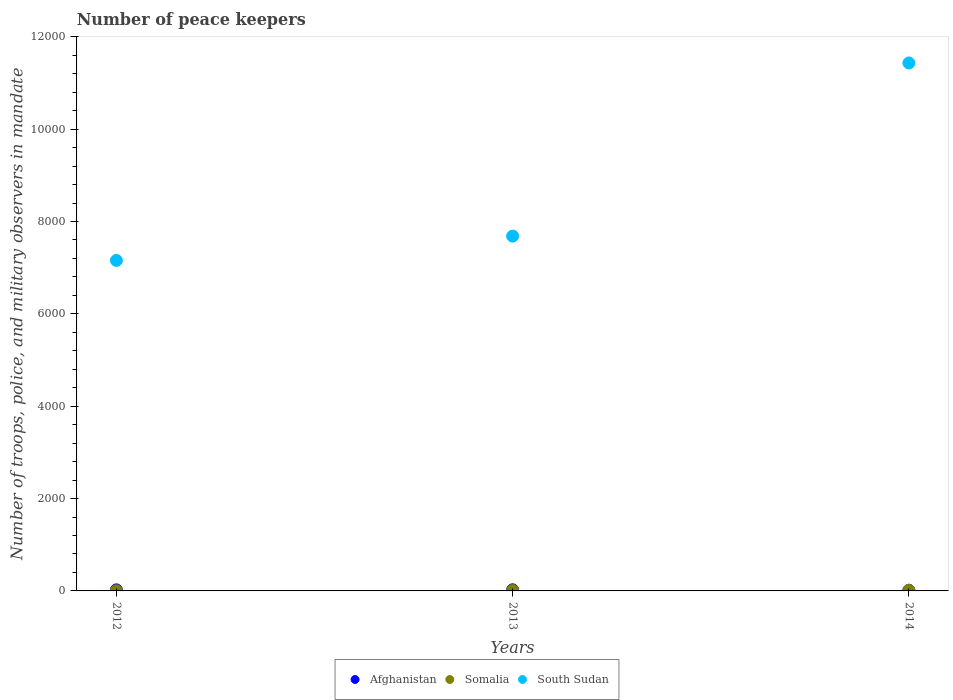How many different coloured dotlines are there?
Provide a short and direct response. 3. Across all years, what is the maximum number of peace keepers in in South Sudan?
Provide a short and direct response. 1.14e+04. Across all years, what is the minimum number of peace keepers in in South Sudan?
Make the answer very short. 7157. What is the total number of peace keepers in in Afghanistan in the graph?
Keep it short and to the point. 63. What is the difference between the number of peace keepers in in Somalia in 2012 and that in 2014?
Offer a very short reply. -9. What is the difference between the number of peace keepers in in Afghanistan in 2014 and the number of peace keepers in in South Sudan in 2012?
Provide a short and direct response. -7142. What is the average number of peace keepers in in South Sudan per year?
Your response must be concise. 8758. In the year 2013, what is the difference between the number of peace keepers in in South Sudan and number of peace keepers in in Somalia?
Give a very brief answer. 7675. What is the ratio of the number of peace keepers in in Afghanistan in 2012 to that in 2014?
Ensure brevity in your answer.  1.53. Is the number of peace keepers in in Afghanistan in 2012 less than that in 2013?
Offer a very short reply. Yes. What is the difference between the highest and the second highest number of peace keepers in in Afghanistan?
Your answer should be compact. 2. Is the sum of the number of peace keepers in in Afghanistan in 2013 and 2014 greater than the maximum number of peace keepers in in South Sudan across all years?
Ensure brevity in your answer.  No. Does the number of peace keepers in in South Sudan monotonically increase over the years?
Offer a terse response. Yes. Is the number of peace keepers in in Afghanistan strictly greater than the number of peace keepers in in South Sudan over the years?
Your answer should be very brief. No. How many years are there in the graph?
Provide a succinct answer. 3. What is the difference between two consecutive major ticks on the Y-axis?
Your answer should be very brief. 2000. Are the values on the major ticks of Y-axis written in scientific E-notation?
Your response must be concise. No. How are the legend labels stacked?
Offer a very short reply. Horizontal. What is the title of the graph?
Provide a short and direct response. Number of peace keepers. Does "Sao Tome and Principe" appear as one of the legend labels in the graph?
Ensure brevity in your answer.  No. What is the label or title of the Y-axis?
Offer a terse response. Number of troops, police, and military observers in mandate. What is the Number of troops, police, and military observers in mandate of Afghanistan in 2012?
Your answer should be compact. 23. What is the Number of troops, police, and military observers in mandate of South Sudan in 2012?
Provide a succinct answer. 7157. What is the Number of troops, police, and military observers in mandate in Somalia in 2013?
Give a very brief answer. 9. What is the Number of troops, police, and military observers in mandate in South Sudan in 2013?
Provide a short and direct response. 7684. What is the Number of troops, police, and military observers in mandate in Afghanistan in 2014?
Give a very brief answer. 15. What is the Number of troops, police, and military observers in mandate in South Sudan in 2014?
Your answer should be very brief. 1.14e+04. Across all years, what is the maximum Number of troops, police, and military observers in mandate of Afghanistan?
Give a very brief answer. 25. Across all years, what is the maximum Number of troops, police, and military observers in mandate in Somalia?
Offer a very short reply. 12. Across all years, what is the maximum Number of troops, police, and military observers in mandate in South Sudan?
Offer a terse response. 1.14e+04. Across all years, what is the minimum Number of troops, police, and military observers in mandate in Somalia?
Keep it short and to the point. 3. Across all years, what is the minimum Number of troops, police, and military observers in mandate of South Sudan?
Give a very brief answer. 7157. What is the total Number of troops, police, and military observers in mandate in Afghanistan in the graph?
Offer a very short reply. 63. What is the total Number of troops, police, and military observers in mandate of South Sudan in the graph?
Provide a succinct answer. 2.63e+04. What is the difference between the Number of troops, police, and military observers in mandate of Afghanistan in 2012 and that in 2013?
Provide a succinct answer. -2. What is the difference between the Number of troops, police, and military observers in mandate of Somalia in 2012 and that in 2013?
Your response must be concise. -6. What is the difference between the Number of troops, police, and military observers in mandate in South Sudan in 2012 and that in 2013?
Ensure brevity in your answer.  -527. What is the difference between the Number of troops, police, and military observers in mandate in South Sudan in 2012 and that in 2014?
Ensure brevity in your answer.  -4276. What is the difference between the Number of troops, police, and military observers in mandate in South Sudan in 2013 and that in 2014?
Offer a very short reply. -3749. What is the difference between the Number of troops, police, and military observers in mandate of Afghanistan in 2012 and the Number of troops, police, and military observers in mandate of South Sudan in 2013?
Keep it short and to the point. -7661. What is the difference between the Number of troops, police, and military observers in mandate in Somalia in 2012 and the Number of troops, police, and military observers in mandate in South Sudan in 2013?
Your response must be concise. -7681. What is the difference between the Number of troops, police, and military observers in mandate in Afghanistan in 2012 and the Number of troops, police, and military observers in mandate in South Sudan in 2014?
Provide a short and direct response. -1.14e+04. What is the difference between the Number of troops, police, and military observers in mandate of Somalia in 2012 and the Number of troops, police, and military observers in mandate of South Sudan in 2014?
Your answer should be very brief. -1.14e+04. What is the difference between the Number of troops, police, and military observers in mandate in Afghanistan in 2013 and the Number of troops, police, and military observers in mandate in Somalia in 2014?
Your answer should be compact. 13. What is the difference between the Number of troops, police, and military observers in mandate in Afghanistan in 2013 and the Number of troops, police, and military observers in mandate in South Sudan in 2014?
Offer a terse response. -1.14e+04. What is the difference between the Number of troops, police, and military observers in mandate of Somalia in 2013 and the Number of troops, police, and military observers in mandate of South Sudan in 2014?
Provide a short and direct response. -1.14e+04. What is the average Number of troops, police, and military observers in mandate of South Sudan per year?
Your answer should be compact. 8758. In the year 2012, what is the difference between the Number of troops, police, and military observers in mandate of Afghanistan and Number of troops, police, and military observers in mandate of Somalia?
Your answer should be very brief. 20. In the year 2012, what is the difference between the Number of troops, police, and military observers in mandate in Afghanistan and Number of troops, police, and military observers in mandate in South Sudan?
Your answer should be very brief. -7134. In the year 2012, what is the difference between the Number of troops, police, and military observers in mandate in Somalia and Number of troops, police, and military observers in mandate in South Sudan?
Provide a short and direct response. -7154. In the year 2013, what is the difference between the Number of troops, police, and military observers in mandate in Afghanistan and Number of troops, police, and military observers in mandate in Somalia?
Offer a terse response. 16. In the year 2013, what is the difference between the Number of troops, police, and military observers in mandate in Afghanistan and Number of troops, police, and military observers in mandate in South Sudan?
Your answer should be compact. -7659. In the year 2013, what is the difference between the Number of troops, police, and military observers in mandate of Somalia and Number of troops, police, and military observers in mandate of South Sudan?
Make the answer very short. -7675. In the year 2014, what is the difference between the Number of troops, police, and military observers in mandate of Afghanistan and Number of troops, police, and military observers in mandate of Somalia?
Keep it short and to the point. 3. In the year 2014, what is the difference between the Number of troops, police, and military observers in mandate in Afghanistan and Number of troops, police, and military observers in mandate in South Sudan?
Your response must be concise. -1.14e+04. In the year 2014, what is the difference between the Number of troops, police, and military observers in mandate in Somalia and Number of troops, police, and military observers in mandate in South Sudan?
Your answer should be very brief. -1.14e+04. What is the ratio of the Number of troops, police, and military observers in mandate in Afghanistan in 2012 to that in 2013?
Offer a very short reply. 0.92. What is the ratio of the Number of troops, police, and military observers in mandate in South Sudan in 2012 to that in 2013?
Offer a very short reply. 0.93. What is the ratio of the Number of troops, police, and military observers in mandate in Afghanistan in 2012 to that in 2014?
Your response must be concise. 1.53. What is the ratio of the Number of troops, police, and military observers in mandate of South Sudan in 2012 to that in 2014?
Keep it short and to the point. 0.63. What is the ratio of the Number of troops, police, and military observers in mandate of Afghanistan in 2013 to that in 2014?
Offer a very short reply. 1.67. What is the ratio of the Number of troops, police, and military observers in mandate in Somalia in 2013 to that in 2014?
Your answer should be very brief. 0.75. What is the ratio of the Number of troops, police, and military observers in mandate in South Sudan in 2013 to that in 2014?
Give a very brief answer. 0.67. What is the difference between the highest and the second highest Number of troops, police, and military observers in mandate in Afghanistan?
Give a very brief answer. 2. What is the difference between the highest and the second highest Number of troops, police, and military observers in mandate in Somalia?
Give a very brief answer. 3. What is the difference between the highest and the second highest Number of troops, police, and military observers in mandate of South Sudan?
Offer a terse response. 3749. What is the difference between the highest and the lowest Number of troops, police, and military observers in mandate in South Sudan?
Provide a short and direct response. 4276. 